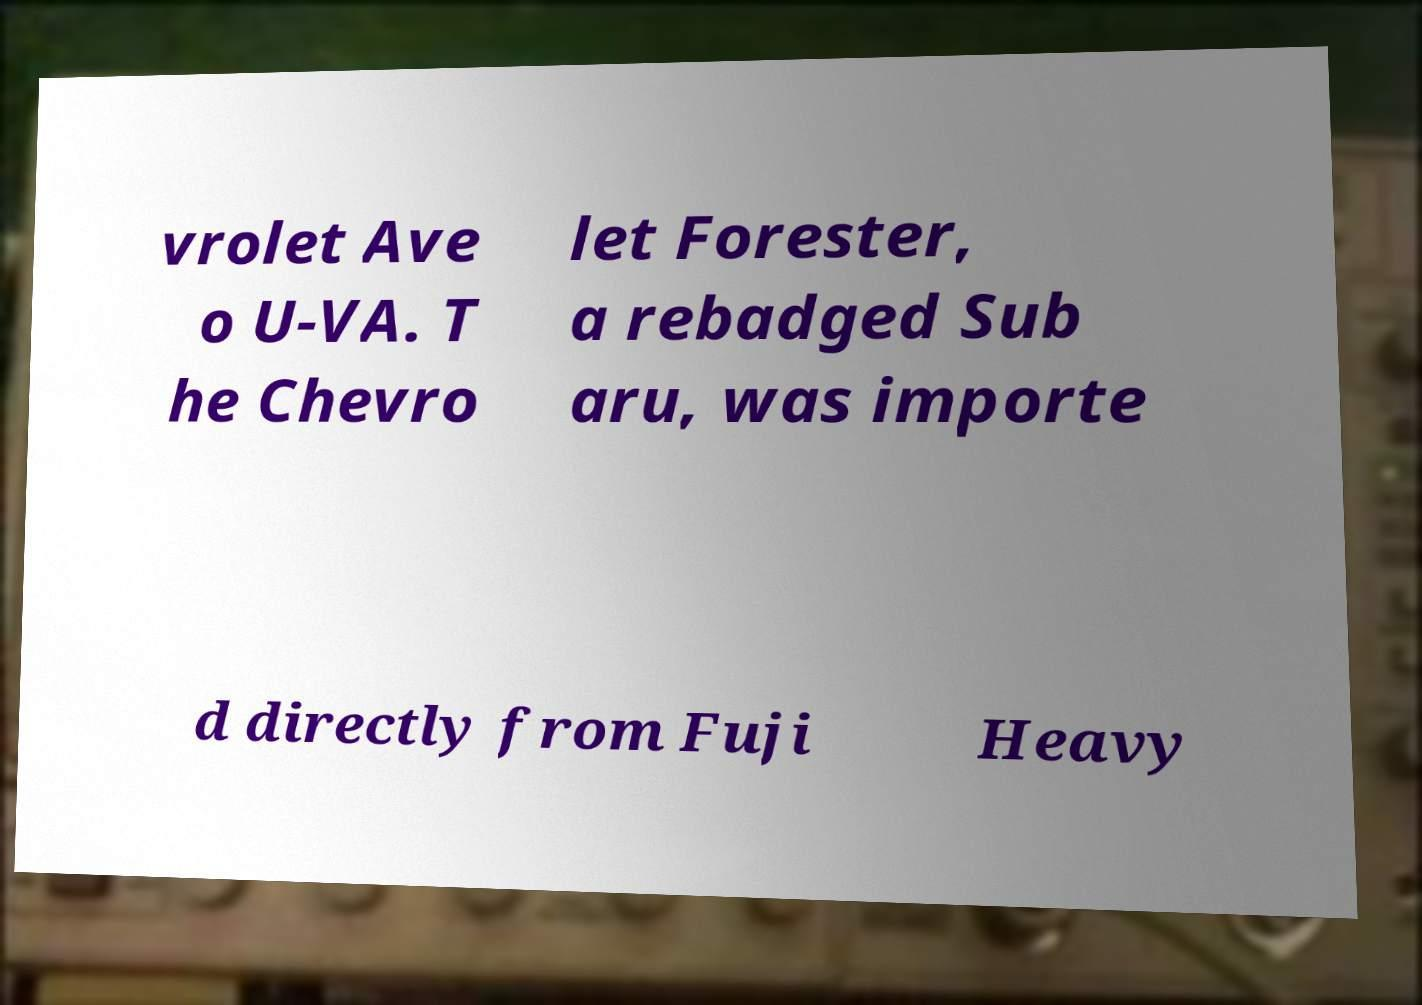I need the written content from this picture converted into text. Can you do that? vrolet Ave o U-VA. T he Chevro let Forester, a rebadged Sub aru, was importe d directly from Fuji Heavy 